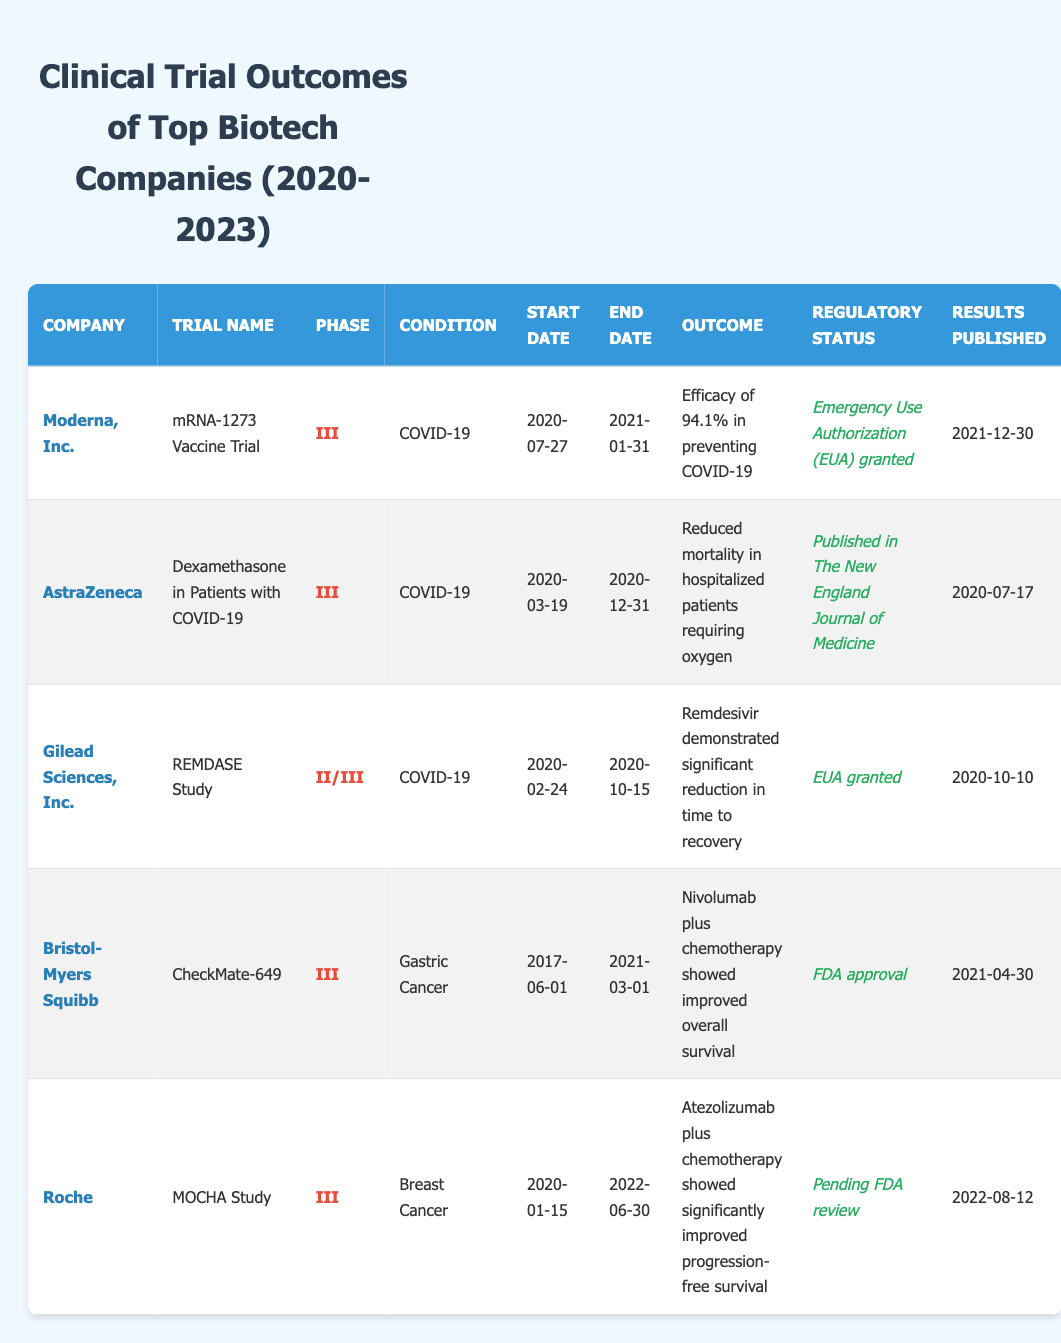What company had a clinical trial outcome published on December 30, 2021? By examining the "Results Published" column, I can see that Moderna, Inc. had its outcome published on December 30, 2021.
Answer: Moderna, Inc Which clinical trial showed a significant reduction in mortality? Looking through the "Outcome" column, the trial "Dexamethasone in Patients with COVID-19" conducted by AstraZeneca reported a reduction in mortality among hospitalized patients requiring oxygen.
Answer: AstraZeneca What was the outcome of the MOCHA Study? The MOCHA Study by Roche had an outcome listed as "Atezolizumab plus chemotherapy showed significantly improved progression-free survival."
Answer: Improved progression-free survival Was Gilead Sciences' REMDASE Study granted Emergency Use Authorization? Reviewing the "Regulatory Status" column for Gilead Sciences' REMDASE Study indicates that it indeed received Emergency Use Authorization (EUA) granted.
Answer: Yes How many companies reported outcomes related to COVID-19? From the table, I see there are three trials related to COVID-19: Moderna, AstraZeneca, and Gilead Sciences. Therefore, the total count is three.
Answer: Three What is the duration of the mRNA-1273 Vaccine Trial? The mRNA-1273 Vaccine Trial began on July 27, 2020, and ended on January 31, 2021. The duration is calculated as follows: January 31, 2021 – July 27, 2020, equaling 6 months and 4 days.
Answer: 6 months and 4 days Which company’s trial concluded last, and when did it end? By comparing the "End Date" values, I determine that Roche's MOCHA Study concluded last on June 30, 2022.
Answer: Roche, June 30, 2022 What percentage efficacy was reported by Moderna in preventing COVID-19? The outcome for the mRNA-1273 Vaccine Trial specified an efficacy of 94.1% in preventing COVID-19.
Answer: 94.1% Which drug combination improved overall survival in gastric cancer patients, according to Bristol-Myers Squibb? The outcome of the CheckMate-649 trial notes that "Nivolumab plus chemotherapy showed improved overall survival," indicating this drug combination was effective.
Answer: Nivolumab plus chemotherapy 